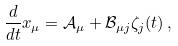Convert formula to latex. <formula><loc_0><loc_0><loc_500><loc_500>\, \frac { d } { d t } x _ { \mu } = \mathcal { A } _ { \mu } + \mathcal { B } _ { \mu j } \zeta _ { j } ( t ) \, ,</formula> 